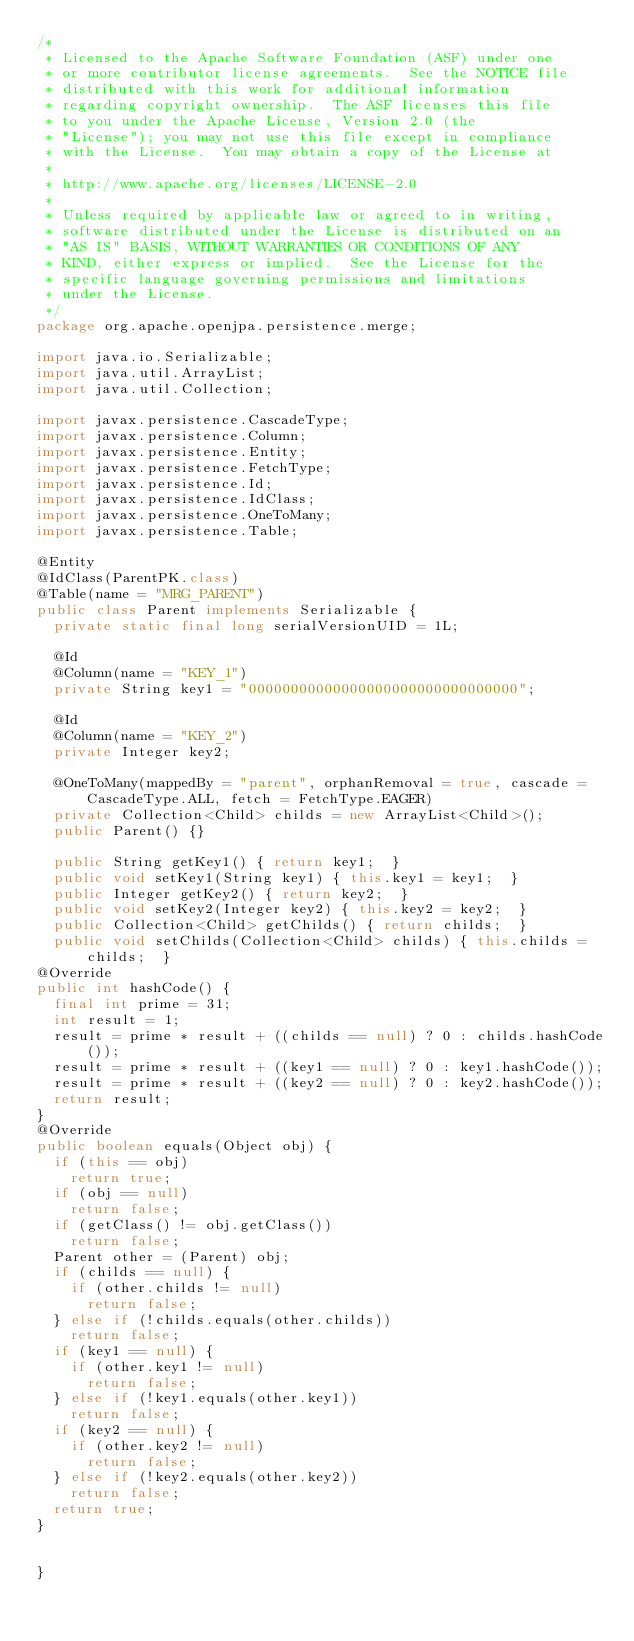<code> <loc_0><loc_0><loc_500><loc_500><_Java_>/*
 * Licensed to the Apache Software Foundation (ASF) under one
 * or more contributor license agreements.  See the NOTICE file
 * distributed with this work for additional information
 * regarding copyright ownership.  The ASF licenses this file
 * to you under the Apache License, Version 2.0 (the
 * "License"); you may not use this file except in compliance
 * with the License.  You may obtain a copy of the License at
 *
 * http://www.apache.org/licenses/LICENSE-2.0
 *
 * Unless required by applicable law or agreed to in writing,
 * software distributed under the License is distributed on an
 * "AS IS" BASIS, WITHOUT WARRANTIES OR CONDITIONS OF ANY
 * KIND, either express or implied.  See the License for the
 * specific language governing permissions and limitations
 * under the License.
 */
package org.apache.openjpa.persistence.merge;

import java.io.Serializable;
import java.util.ArrayList;
import java.util.Collection;

import javax.persistence.CascadeType;
import javax.persistence.Column;
import javax.persistence.Entity;
import javax.persistence.FetchType;
import javax.persistence.Id;
import javax.persistence.IdClass;
import javax.persistence.OneToMany;
import javax.persistence.Table;

@Entity
@IdClass(ParentPK.class)
@Table(name = "MRG_PARENT")
public class Parent implements Serializable {
  private static final long serialVersionUID = 1L;

  @Id
  @Column(name = "KEY_1")
  private String key1 = "00000000000000000000000000000000";

  @Id
  @Column(name = "KEY_2")
  private Integer key2;

  @OneToMany(mappedBy = "parent", orphanRemoval = true, cascade = CascadeType.ALL, fetch = FetchType.EAGER)
  private Collection<Child> childs = new ArrayList<Child>();
  public Parent() {}

  public String getKey1() { return key1;  }
  public void setKey1(String key1) { this.key1 = key1;  }
  public Integer getKey2() { return key2;  }
  public void setKey2(Integer key2) { this.key2 = key2;  }
  public Collection<Child> getChilds() { return childs;  }
  public void setChilds(Collection<Child> childs) { this.childs = childs;  }
@Override
public int hashCode() {
	final int prime = 31;
	int result = 1;
	result = prime * result + ((childs == null) ? 0 : childs.hashCode());
	result = prime * result + ((key1 == null) ? 0 : key1.hashCode());
	result = prime * result + ((key2 == null) ? 0 : key2.hashCode());
	return result;
}
@Override
public boolean equals(Object obj) {
	if (this == obj)
		return true;
	if (obj == null)
		return false;
	if (getClass() != obj.getClass())
		return false;
	Parent other = (Parent) obj;
	if (childs == null) {
		if (other.childs != null)
			return false;
	} else if (!childs.equals(other.childs))
		return false;
	if (key1 == null) {
		if (other.key1 != null)
			return false;
	} else if (!key1.equals(other.key1))
		return false;
	if (key2 == null) {
		if (other.key2 != null)
			return false;
	} else if (!key2.equals(other.key2))
		return false;
	return true;
}
  
  
}
</code> 